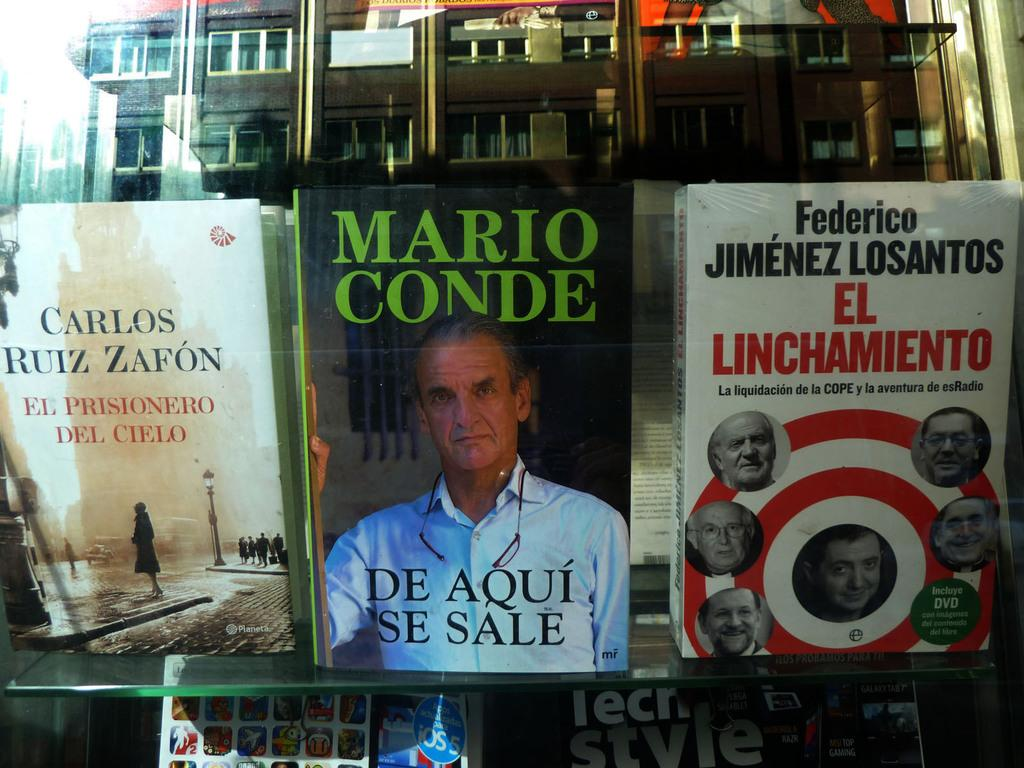<image>
Describe the image concisely. A book by Mario Conde is in the center of a glass shelf. 